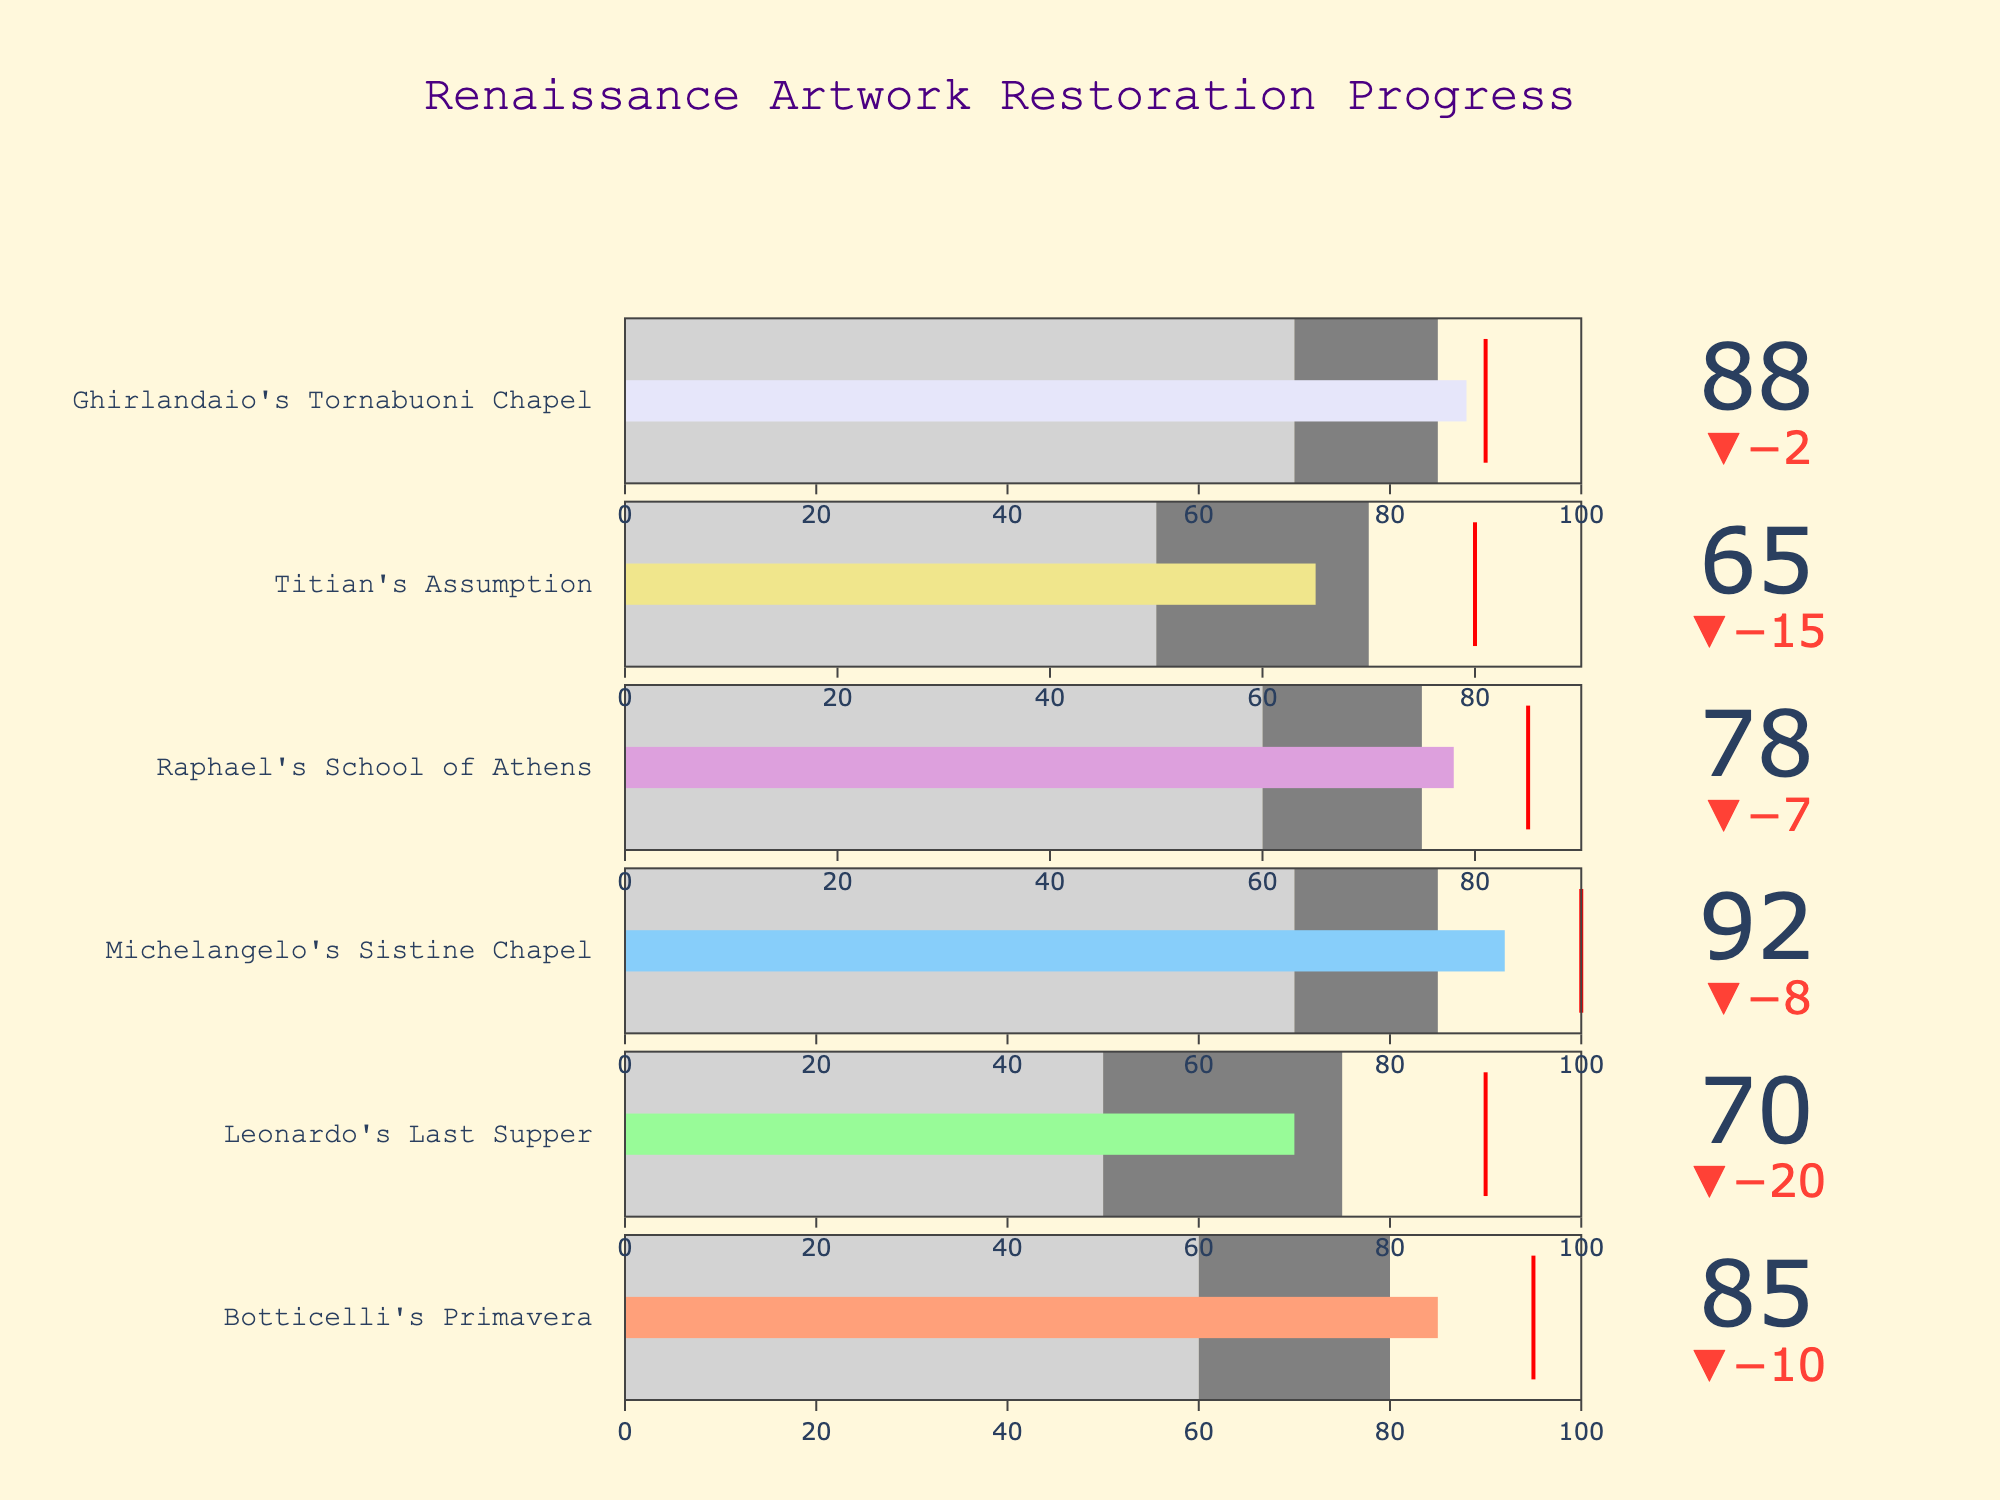Which restoration project has the highest progress compared to its target? To find the project with the highest progress, look for the indicator where the actual value is closest to or surpasses the target. The Sistine Chapel by Michelangelo has an actual value of 92, which is closest to its target of 100.
Answer: Michelangelo's Sistine Chapel How many projects have exceeded their target values? Check each project's actual value against its target. None of the projects have actual values exceeding their targets; all actual values are below their targets.
Answer: 0 Which artwork has the lowest progress value? To determine the artwork with the lowest progress value, examine all the actual values and identify the smallest one. The progress value of Titian's Assumption is the lowest at 65.
Answer: Titian's Assumption What is the average progress across all the projects? Add up all the actual progress values and divide by the number of projects: (85 + 70 + 92 + 78 + 65 + 88) / 6 = 478 / 6 = 79.67.
Answer: 79.67 Which artwork has the smallest gap between its actual value and target? Calculate the difference between actual and target for each project and find the smallest difference. The Ghirlandaio's Tornabuoni Chapel has the smallest gap:
Answer: Ghirlandaio's Tornabuoni Chapel How does the progress of Raphael's School of Athens compare to that of Michelangelo's Sistine Chapel? Compare the actual values of the two projects. Raphael's School of Athens has a progress value of 78, while Michelangelo's Sistine Chapel has 92, making the Sistine Chapel have higher progress.
Answer: Michelangelo's Sistine Chapel Are there any projects where the progress is within the second range (Range2)? To find out, compare the actual value of each project to its respective second range (Range2) value. Raphael's School of Athens has an actual value of 78 which is within its Range2 of 75.
Answer: Raphael's School of Athens Which artwork is closest to reaching its target? Determine how close each actual value is to its target and find the smallest difference. Ghirlandaio's Tornabuoni Chapel has an actual value of 88, just 2 units short of its target of 90.
Answer: Ghirlandaio's Tornabuoni Chapel What are the colors of the progress bars for Botticelli's Primavera and Leonardo's Last Supper? Look at the figure to identify the colors used. Botticelli's Primavera progress bar is salmon-colored, and Leonardo's Last Supper progress bar is light green.
Answer: Salmon and light green Which artwork has a target value of 85? Identify the artwork by its target value from the visual representation. Raphael's School of Athens has a target value of 85.
Answer: Raphael's School of Athens 